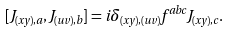<formula> <loc_0><loc_0><loc_500><loc_500>[ J _ { ( x y ) , a } , J _ { ( u v ) , b } ] = i \delta _ { ( x y ) , ( u v ) } f ^ { a b c } J _ { ( x y ) , c } .</formula> 